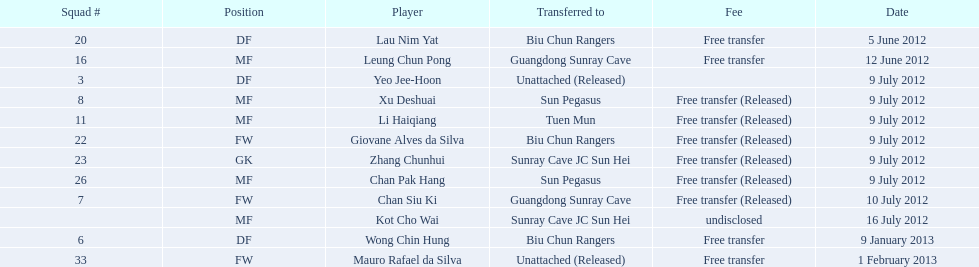Who is the primary player indicated? Lau Nim Yat. 